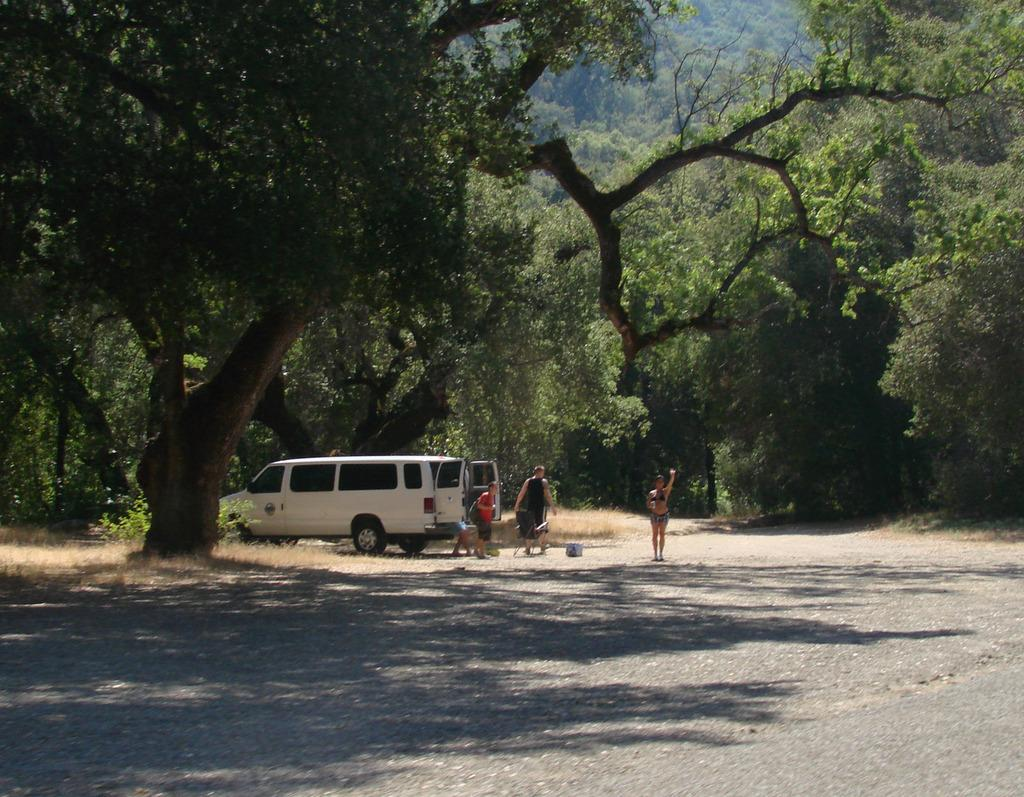What is the main feature in the foreground of the picture? There is a road in the foreground of the picture. What can be seen in the center of the picture? There are trees, grass, a vehicle, people, and other objects in the center of the picture. Are there any natural elements visible in the center of the picture? Yes, there is grass in the center of the picture. What is the condition of the trees at the top of the picture? There are trees at the top of the picture. What type of growth can be seen on the frog in the picture? There is no frog present in the picture, so there is no growth to observe. What season is depicted in the image, considering the presence of trees and grass? The provided facts do not mention any specific season, so it cannot be determined from the image. 